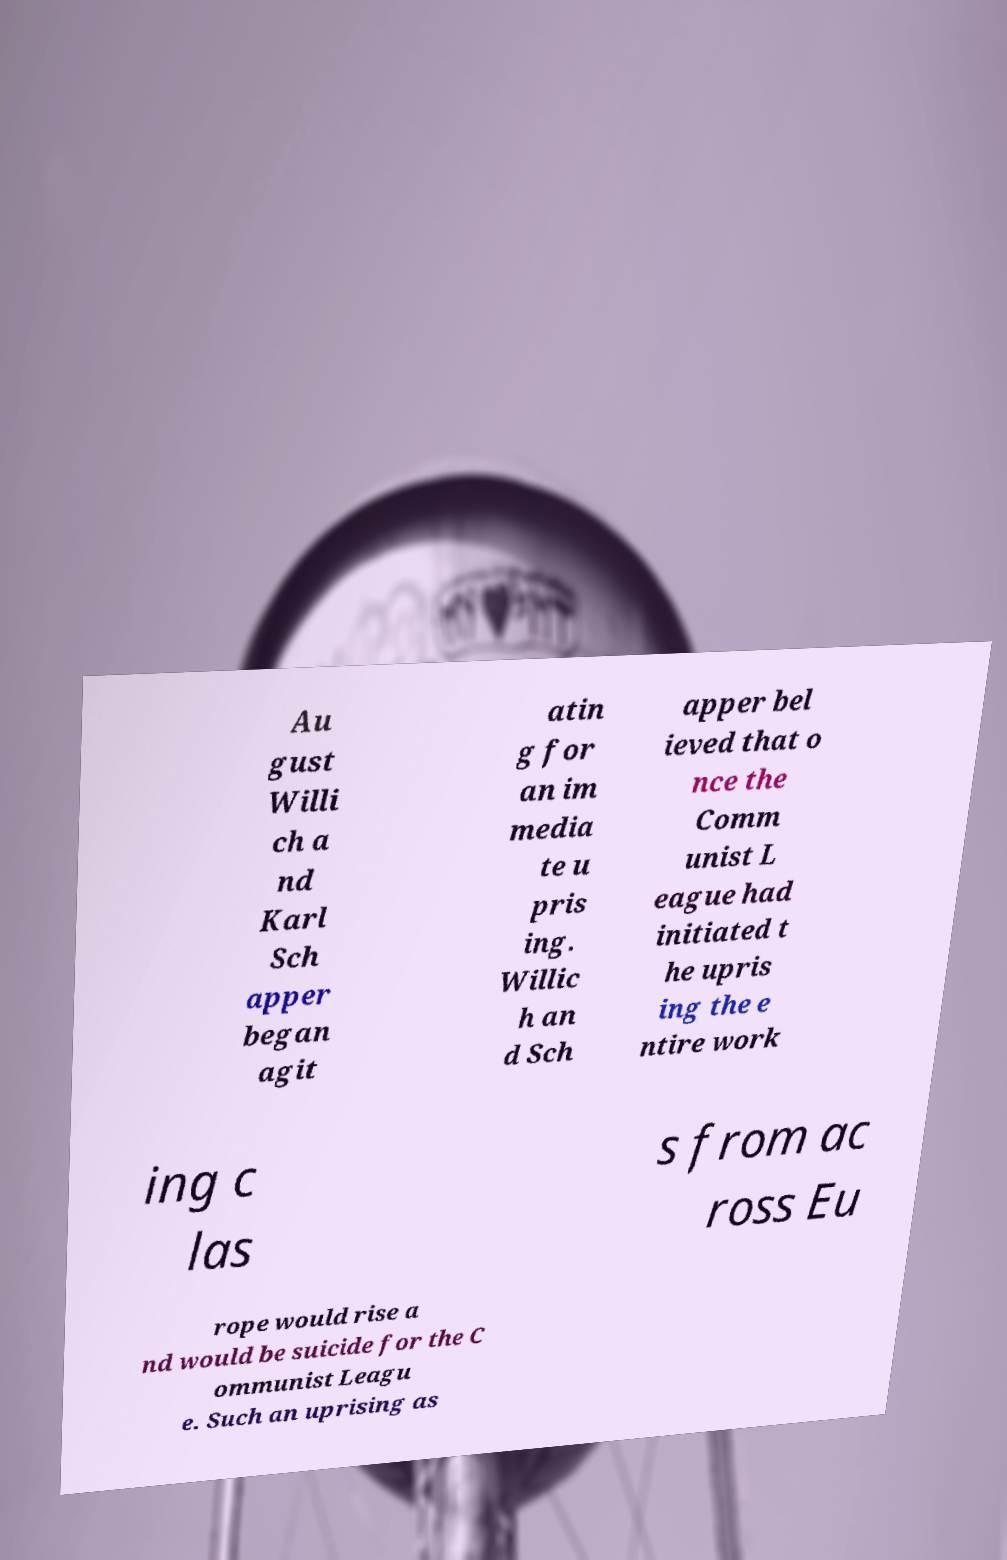There's text embedded in this image that I need extracted. Can you transcribe it verbatim? Au gust Willi ch a nd Karl Sch apper began agit atin g for an im media te u pris ing. Willic h an d Sch apper bel ieved that o nce the Comm unist L eague had initiated t he upris ing the e ntire work ing c las s from ac ross Eu rope would rise a nd would be suicide for the C ommunist Leagu e. Such an uprising as 